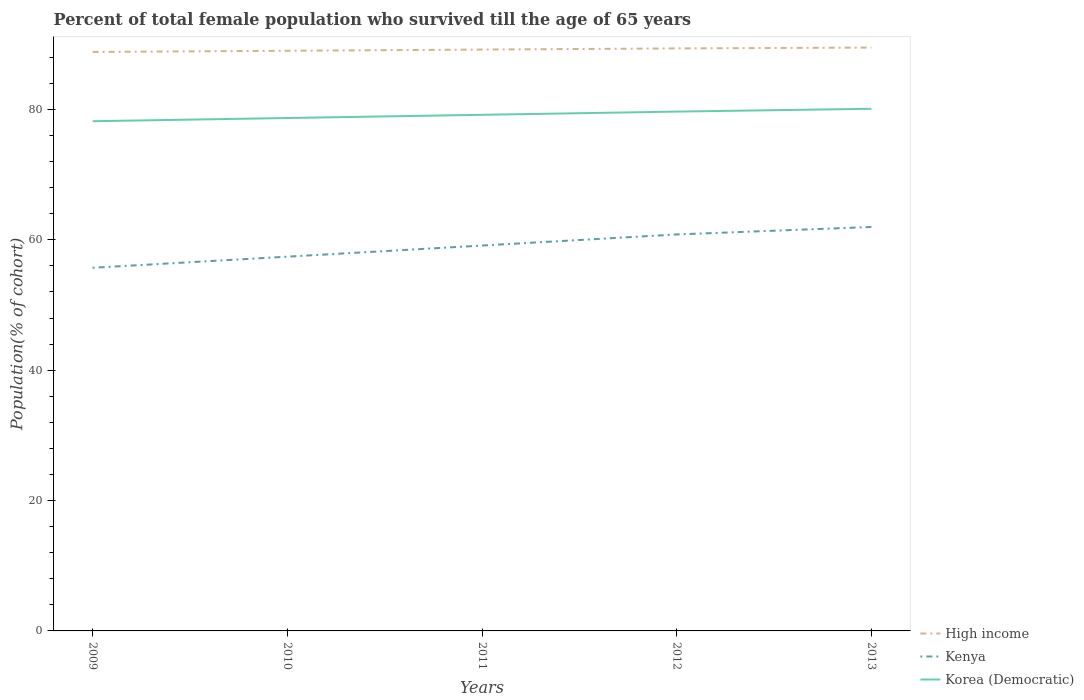How many different coloured lines are there?
Your response must be concise. 3. Does the line corresponding to High income intersect with the line corresponding to Korea (Democratic)?
Ensure brevity in your answer.  No. Across all years, what is the maximum percentage of total female population who survived till the age of 65 years in High income?
Ensure brevity in your answer.  88.81. What is the total percentage of total female population who survived till the age of 65 years in High income in the graph?
Offer a very short reply. -0.18. What is the difference between the highest and the second highest percentage of total female population who survived till the age of 65 years in High income?
Your response must be concise. 0.67. What is the difference between two consecutive major ticks on the Y-axis?
Keep it short and to the point. 20. Are the values on the major ticks of Y-axis written in scientific E-notation?
Your answer should be very brief. No. Does the graph contain grids?
Provide a short and direct response. No. Where does the legend appear in the graph?
Your answer should be compact. Bottom right. How many legend labels are there?
Your response must be concise. 3. How are the legend labels stacked?
Your answer should be very brief. Vertical. What is the title of the graph?
Keep it short and to the point. Percent of total female population who survived till the age of 65 years. Does "Somalia" appear as one of the legend labels in the graph?
Ensure brevity in your answer.  No. What is the label or title of the Y-axis?
Provide a short and direct response. Population(% of cohort). What is the Population(% of cohort) in High income in 2009?
Ensure brevity in your answer.  88.81. What is the Population(% of cohort) in Kenya in 2009?
Your answer should be very brief. 55.7. What is the Population(% of cohort) of Korea (Democratic) in 2009?
Your answer should be compact. 78.19. What is the Population(% of cohort) of High income in 2010?
Offer a very short reply. 88.99. What is the Population(% of cohort) in Kenya in 2010?
Ensure brevity in your answer.  57.41. What is the Population(% of cohort) in Korea (Democratic) in 2010?
Your answer should be very brief. 78.68. What is the Population(% of cohort) of High income in 2011?
Provide a short and direct response. 89.17. What is the Population(% of cohort) of Kenya in 2011?
Provide a short and direct response. 59.11. What is the Population(% of cohort) of Korea (Democratic) in 2011?
Keep it short and to the point. 79.17. What is the Population(% of cohort) of High income in 2012?
Your answer should be very brief. 89.35. What is the Population(% of cohort) of Kenya in 2012?
Keep it short and to the point. 60.82. What is the Population(% of cohort) in Korea (Democratic) in 2012?
Make the answer very short. 79.66. What is the Population(% of cohort) in High income in 2013?
Provide a succinct answer. 89.48. What is the Population(% of cohort) of Kenya in 2013?
Ensure brevity in your answer.  61.96. What is the Population(% of cohort) in Korea (Democratic) in 2013?
Provide a succinct answer. 80.09. Across all years, what is the maximum Population(% of cohort) of High income?
Your answer should be compact. 89.48. Across all years, what is the maximum Population(% of cohort) in Kenya?
Give a very brief answer. 61.96. Across all years, what is the maximum Population(% of cohort) in Korea (Democratic)?
Ensure brevity in your answer.  80.09. Across all years, what is the minimum Population(% of cohort) of High income?
Offer a terse response. 88.81. Across all years, what is the minimum Population(% of cohort) of Kenya?
Provide a short and direct response. 55.7. Across all years, what is the minimum Population(% of cohort) of Korea (Democratic)?
Your answer should be compact. 78.19. What is the total Population(% of cohort) in High income in the graph?
Offer a terse response. 445.81. What is the total Population(% of cohort) in Kenya in the graph?
Ensure brevity in your answer.  295.01. What is the total Population(% of cohort) in Korea (Democratic) in the graph?
Provide a short and direct response. 395.79. What is the difference between the Population(% of cohort) of High income in 2009 and that in 2010?
Offer a very short reply. -0.18. What is the difference between the Population(% of cohort) in Kenya in 2009 and that in 2010?
Your answer should be compact. -1.7. What is the difference between the Population(% of cohort) of Korea (Democratic) in 2009 and that in 2010?
Provide a succinct answer. -0.49. What is the difference between the Population(% of cohort) in High income in 2009 and that in 2011?
Your answer should be compact. -0.36. What is the difference between the Population(% of cohort) in Kenya in 2009 and that in 2011?
Offer a terse response. -3.41. What is the difference between the Population(% of cohort) of Korea (Democratic) in 2009 and that in 2011?
Your answer should be compact. -0.98. What is the difference between the Population(% of cohort) of High income in 2009 and that in 2012?
Make the answer very short. -0.54. What is the difference between the Population(% of cohort) of Kenya in 2009 and that in 2012?
Make the answer very short. -5.11. What is the difference between the Population(% of cohort) in Korea (Democratic) in 2009 and that in 2012?
Make the answer very short. -1.47. What is the difference between the Population(% of cohort) in High income in 2009 and that in 2013?
Provide a short and direct response. -0.67. What is the difference between the Population(% of cohort) in Kenya in 2009 and that in 2013?
Offer a terse response. -6.26. What is the difference between the Population(% of cohort) of Korea (Democratic) in 2009 and that in 2013?
Make the answer very short. -1.91. What is the difference between the Population(% of cohort) in High income in 2010 and that in 2011?
Give a very brief answer. -0.18. What is the difference between the Population(% of cohort) of Kenya in 2010 and that in 2011?
Your response must be concise. -1.7. What is the difference between the Population(% of cohort) in Korea (Democratic) in 2010 and that in 2011?
Provide a short and direct response. -0.49. What is the difference between the Population(% of cohort) in High income in 2010 and that in 2012?
Provide a short and direct response. -0.36. What is the difference between the Population(% of cohort) in Kenya in 2010 and that in 2012?
Offer a very short reply. -3.41. What is the difference between the Population(% of cohort) in Korea (Democratic) in 2010 and that in 2012?
Keep it short and to the point. -0.98. What is the difference between the Population(% of cohort) of High income in 2010 and that in 2013?
Provide a short and direct response. -0.49. What is the difference between the Population(% of cohort) of Kenya in 2010 and that in 2013?
Provide a short and direct response. -4.55. What is the difference between the Population(% of cohort) of Korea (Democratic) in 2010 and that in 2013?
Give a very brief answer. -1.42. What is the difference between the Population(% of cohort) of High income in 2011 and that in 2012?
Provide a succinct answer. -0.18. What is the difference between the Population(% of cohort) in Kenya in 2011 and that in 2012?
Your answer should be compact. -1.7. What is the difference between the Population(% of cohort) of Korea (Democratic) in 2011 and that in 2012?
Your answer should be very brief. -0.49. What is the difference between the Population(% of cohort) of High income in 2011 and that in 2013?
Your response must be concise. -0.31. What is the difference between the Population(% of cohort) of Kenya in 2011 and that in 2013?
Your answer should be compact. -2.85. What is the difference between the Population(% of cohort) of Korea (Democratic) in 2011 and that in 2013?
Provide a succinct answer. -0.92. What is the difference between the Population(% of cohort) of High income in 2012 and that in 2013?
Keep it short and to the point. -0.13. What is the difference between the Population(% of cohort) of Kenya in 2012 and that in 2013?
Your answer should be very brief. -1.15. What is the difference between the Population(% of cohort) of Korea (Democratic) in 2012 and that in 2013?
Ensure brevity in your answer.  -0.43. What is the difference between the Population(% of cohort) in High income in 2009 and the Population(% of cohort) in Kenya in 2010?
Offer a terse response. 31.4. What is the difference between the Population(% of cohort) of High income in 2009 and the Population(% of cohort) of Korea (Democratic) in 2010?
Your answer should be very brief. 10.13. What is the difference between the Population(% of cohort) of Kenya in 2009 and the Population(% of cohort) of Korea (Democratic) in 2010?
Offer a very short reply. -22.97. What is the difference between the Population(% of cohort) in High income in 2009 and the Population(% of cohort) in Kenya in 2011?
Provide a short and direct response. 29.7. What is the difference between the Population(% of cohort) of High income in 2009 and the Population(% of cohort) of Korea (Democratic) in 2011?
Ensure brevity in your answer.  9.64. What is the difference between the Population(% of cohort) of Kenya in 2009 and the Population(% of cohort) of Korea (Democratic) in 2011?
Keep it short and to the point. -23.46. What is the difference between the Population(% of cohort) of High income in 2009 and the Population(% of cohort) of Kenya in 2012?
Your answer should be compact. 28. What is the difference between the Population(% of cohort) in High income in 2009 and the Population(% of cohort) in Korea (Democratic) in 2012?
Keep it short and to the point. 9.15. What is the difference between the Population(% of cohort) in Kenya in 2009 and the Population(% of cohort) in Korea (Democratic) in 2012?
Ensure brevity in your answer.  -23.96. What is the difference between the Population(% of cohort) of High income in 2009 and the Population(% of cohort) of Kenya in 2013?
Your answer should be compact. 26.85. What is the difference between the Population(% of cohort) of High income in 2009 and the Population(% of cohort) of Korea (Democratic) in 2013?
Your answer should be compact. 8.72. What is the difference between the Population(% of cohort) in Kenya in 2009 and the Population(% of cohort) in Korea (Democratic) in 2013?
Your answer should be compact. -24.39. What is the difference between the Population(% of cohort) of High income in 2010 and the Population(% of cohort) of Kenya in 2011?
Your answer should be compact. 29.88. What is the difference between the Population(% of cohort) in High income in 2010 and the Population(% of cohort) in Korea (Democratic) in 2011?
Your answer should be compact. 9.82. What is the difference between the Population(% of cohort) of Kenya in 2010 and the Population(% of cohort) of Korea (Democratic) in 2011?
Ensure brevity in your answer.  -21.76. What is the difference between the Population(% of cohort) in High income in 2010 and the Population(% of cohort) in Kenya in 2012?
Give a very brief answer. 28.18. What is the difference between the Population(% of cohort) of High income in 2010 and the Population(% of cohort) of Korea (Democratic) in 2012?
Your answer should be very brief. 9.33. What is the difference between the Population(% of cohort) in Kenya in 2010 and the Population(% of cohort) in Korea (Democratic) in 2012?
Provide a succinct answer. -22.25. What is the difference between the Population(% of cohort) of High income in 2010 and the Population(% of cohort) of Kenya in 2013?
Your answer should be very brief. 27.03. What is the difference between the Population(% of cohort) in High income in 2010 and the Population(% of cohort) in Korea (Democratic) in 2013?
Give a very brief answer. 8.9. What is the difference between the Population(% of cohort) in Kenya in 2010 and the Population(% of cohort) in Korea (Democratic) in 2013?
Your response must be concise. -22.68. What is the difference between the Population(% of cohort) in High income in 2011 and the Population(% of cohort) in Kenya in 2012?
Make the answer very short. 28.36. What is the difference between the Population(% of cohort) of High income in 2011 and the Population(% of cohort) of Korea (Democratic) in 2012?
Provide a short and direct response. 9.51. What is the difference between the Population(% of cohort) of Kenya in 2011 and the Population(% of cohort) of Korea (Democratic) in 2012?
Provide a short and direct response. -20.55. What is the difference between the Population(% of cohort) of High income in 2011 and the Population(% of cohort) of Kenya in 2013?
Keep it short and to the point. 27.21. What is the difference between the Population(% of cohort) of High income in 2011 and the Population(% of cohort) of Korea (Democratic) in 2013?
Your answer should be very brief. 9.08. What is the difference between the Population(% of cohort) in Kenya in 2011 and the Population(% of cohort) in Korea (Democratic) in 2013?
Provide a short and direct response. -20.98. What is the difference between the Population(% of cohort) in High income in 2012 and the Population(% of cohort) in Kenya in 2013?
Offer a very short reply. 27.39. What is the difference between the Population(% of cohort) of High income in 2012 and the Population(% of cohort) of Korea (Democratic) in 2013?
Ensure brevity in your answer.  9.26. What is the difference between the Population(% of cohort) in Kenya in 2012 and the Population(% of cohort) in Korea (Democratic) in 2013?
Provide a succinct answer. -19.28. What is the average Population(% of cohort) of High income per year?
Your answer should be compact. 89.16. What is the average Population(% of cohort) of Kenya per year?
Your response must be concise. 59. What is the average Population(% of cohort) of Korea (Democratic) per year?
Your answer should be compact. 79.16. In the year 2009, what is the difference between the Population(% of cohort) in High income and Population(% of cohort) in Kenya?
Your response must be concise. 33.11. In the year 2009, what is the difference between the Population(% of cohort) in High income and Population(% of cohort) in Korea (Democratic)?
Provide a succinct answer. 10.63. In the year 2009, what is the difference between the Population(% of cohort) of Kenya and Population(% of cohort) of Korea (Democratic)?
Keep it short and to the point. -22.48. In the year 2010, what is the difference between the Population(% of cohort) of High income and Population(% of cohort) of Kenya?
Make the answer very short. 31.58. In the year 2010, what is the difference between the Population(% of cohort) in High income and Population(% of cohort) in Korea (Democratic)?
Your answer should be very brief. 10.32. In the year 2010, what is the difference between the Population(% of cohort) in Kenya and Population(% of cohort) in Korea (Democratic)?
Keep it short and to the point. -21.27. In the year 2011, what is the difference between the Population(% of cohort) in High income and Population(% of cohort) in Kenya?
Offer a very short reply. 30.06. In the year 2011, what is the difference between the Population(% of cohort) of High income and Population(% of cohort) of Korea (Democratic)?
Keep it short and to the point. 10.01. In the year 2011, what is the difference between the Population(% of cohort) of Kenya and Population(% of cohort) of Korea (Democratic)?
Offer a terse response. -20.06. In the year 2012, what is the difference between the Population(% of cohort) of High income and Population(% of cohort) of Kenya?
Provide a succinct answer. 28.54. In the year 2012, what is the difference between the Population(% of cohort) in High income and Population(% of cohort) in Korea (Democratic)?
Offer a very short reply. 9.69. In the year 2012, what is the difference between the Population(% of cohort) of Kenya and Population(% of cohort) of Korea (Democratic)?
Your answer should be very brief. -18.84. In the year 2013, what is the difference between the Population(% of cohort) of High income and Population(% of cohort) of Kenya?
Offer a very short reply. 27.52. In the year 2013, what is the difference between the Population(% of cohort) in High income and Population(% of cohort) in Korea (Democratic)?
Offer a terse response. 9.39. In the year 2013, what is the difference between the Population(% of cohort) in Kenya and Population(% of cohort) in Korea (Democratic)?
Offer a very short reply. -18.13. What is the ratio of the Population(% of cohort) in High income in 2009 to that in 2010?
Your answer should be very brief. 1. What is the ratio of the Population(% of cohort) of Kenya in 2009 to that in 2010?
Keep it short and to the point. 0.97. What is the ratio of the Population(% of cohort) of Kenya in 2009 to that in 2011?
Offer a terse response. 0.94. What is the ratio of the Population(% of cohort) in Korea (Democratic) in 2009 to that in 2011?
Provide a short and direct response. 0.99. What is the ratio of the Population(% of cohort) of High income in 2009 to that in 2012?
Keep it short and to the point. 0.99. What is the ratio of the Population(% of cohort) in Kenya in 2009 to that in 2012?
Provide a succinct answer. 0.92. What is the ratio of the Population(% of cohort) in Korea (Democratic) in 2009 to that in 2012?
Give a very brief answer. 0.98. What is the ratio of the Population(% of cohort) in High income in 2009 to that in 2013?
Offer a terse response. 0.99. What is the ratio of the Population(% of cohort) in Kenya in 2009 to that in 2013?
Make the answer very short. 0.9. What is the ratio of the Population(% of cohort) of Korea (Democratic) in 2009 to that in 2013?
Offer a terse response. 0.98. What is the ratio of the Population(% of cohort) of Kenya in 2010 to that in 2011?
Your response must be concise. 0.97. What is the ratio of the Population(% of cohort) of Kenya in 2010 to that in 2012?
Provide a short and direct response. 0.94. What is the ratio of the Population(% of cohort) of High income in 2010 to that in 2013?
Offer a terse response. 0.99. What is the ratio of the Population(% of cohort) of Kenya in 2010 to that in 2013?
Keep it short and to the point. 0.93. What is the ratio of the Population(% of cohort) in Korea (Democratic) in 2010 to that in 2013?
Keep it short and to the point. 0.98. What is the ratio of the Population(% of cohort) in High income in 2011 to that in 2012?
Keep it short and to the point. 1. What is the ratio of the Population(% of cohort) of Kenya in 2011 to that in 2012?
Provide a succinct answer. 0.97. What is the ratio of the Population(% of cohort) of Korea (Democratic) in 2011 to that in 2012?
Offer a very short reply. 0.99. What is the ratio of the Population(% of cohort) in High income in 2011 to that in 2013?
Give a very brief answer. 1. What is the ratio of the Population(% of cohort) in Kenya in 2011 to that in 2013?
Your response must be concise. 0.95. What is the ratio of the Population(% of cohort) in High income in 2012 to that in 2013?
Provide a short and direct response. 1. What is the ratio of the Population(% of cohort) in Kenya in 2012 to that in 2013?
Keep it short and to the point. 0.98. What is the ratio of the Population(% of cohort) of Korea (Democratic) in 2012 to that in 2013?
Your response must be concise. 0.99. What is the difference between the highest and the second highest Population(% of cohort) in High income?
Provide a short and direct response. 0.13. What is the difference between the highest and the second highest Population(% of cohort) of Kenya?
Your answer should be very brief. 1.15. What is the difference between the highest and the second highest Population(% of cohort) of Korea (Democratic)?
Make the answer very short. 0.43. What is the difference between the highest and the lowest Population(% of cohort) in High income?
Keep it short and to the point. 0.67. What is the difference between the highest and the lowest Population(% of cohort) in Kenya?
Offer a terse response. 6.26. What is the difference between the highest and the lowest Population(% of cohort) of Korea (Democratic)?
Keep it short and to the point. 1.91. 